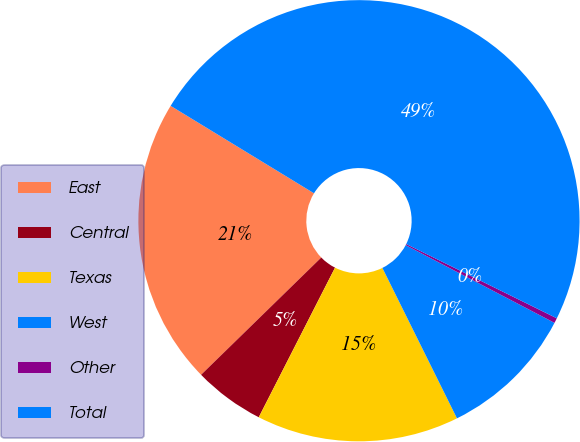Convert chart. <chart><loc_0><loc_0><loc_500><loc_500><pie_chart><fcel>East<fcel>Central<fcel>Texas<fcel>West<fcel>Other<fcel>Total<nl><fcel>21.02%<fcel>5.19%<fcel>14.83%<fcel>10.01%<fcel>0.37%<fcel>48.57%<nl></chart> 